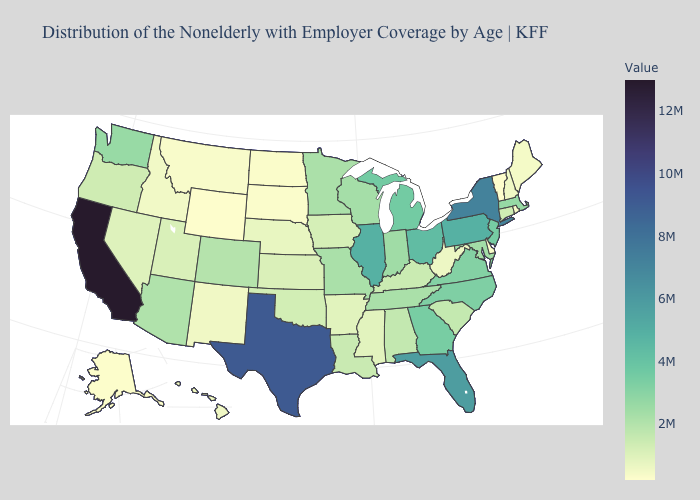Among the states that border Florida , does Georgia have the highest value?
Write a very short answer. Yes. Does Montana have the highest value in the West?
Be succinct. No. Does the map have missing data?
Concise answer only. No. Which states hav the highest value in the MidWest?
Be succinct. Illinois. 